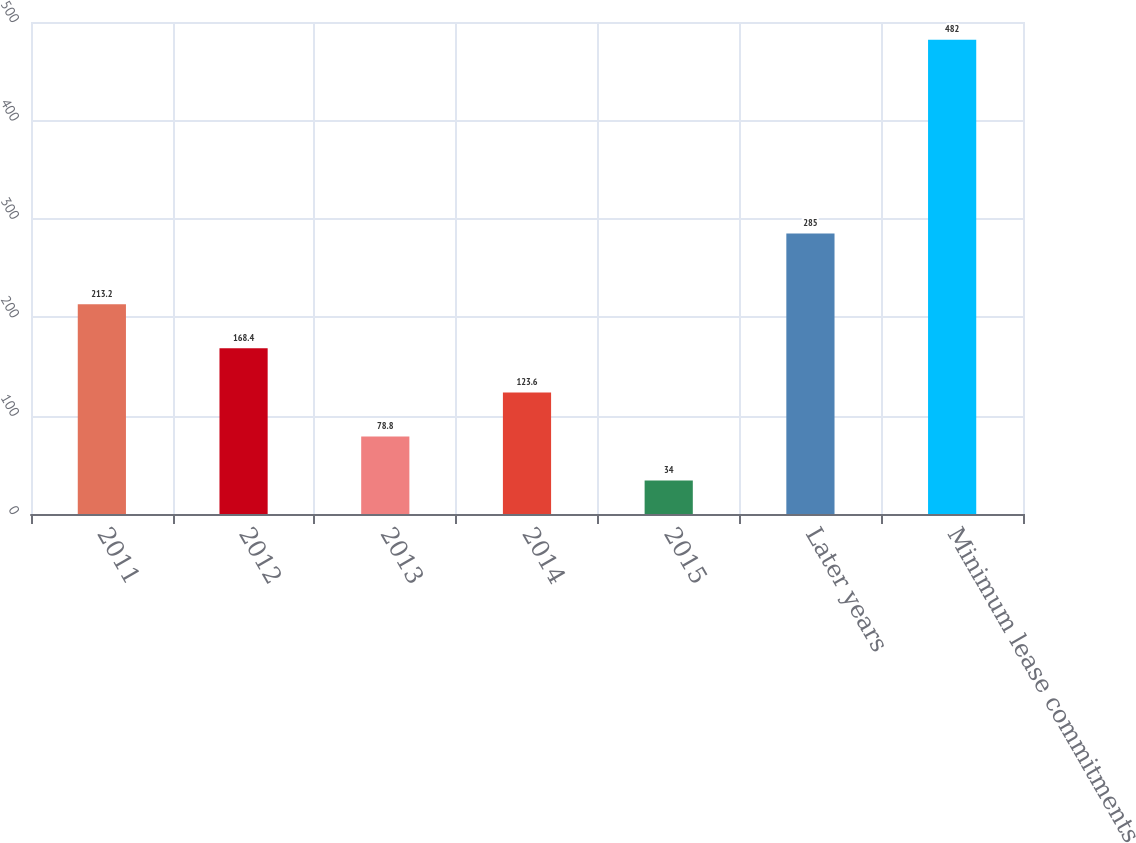Convert chart to OTSL. <chart><loc_0><loc_0><loc_500><loc_500><bar_chart><fcel>2011<fcel>2012<fcel>2013<fcel>2014<fcel>2015<fcel>Later years<fcel>Minimum lease commitments<nl><fcel>213.2<fcel>168.4<fcel>78.8<fcel>123.6<fcel>34<fcel>285<fcel>482<nl></chart> 